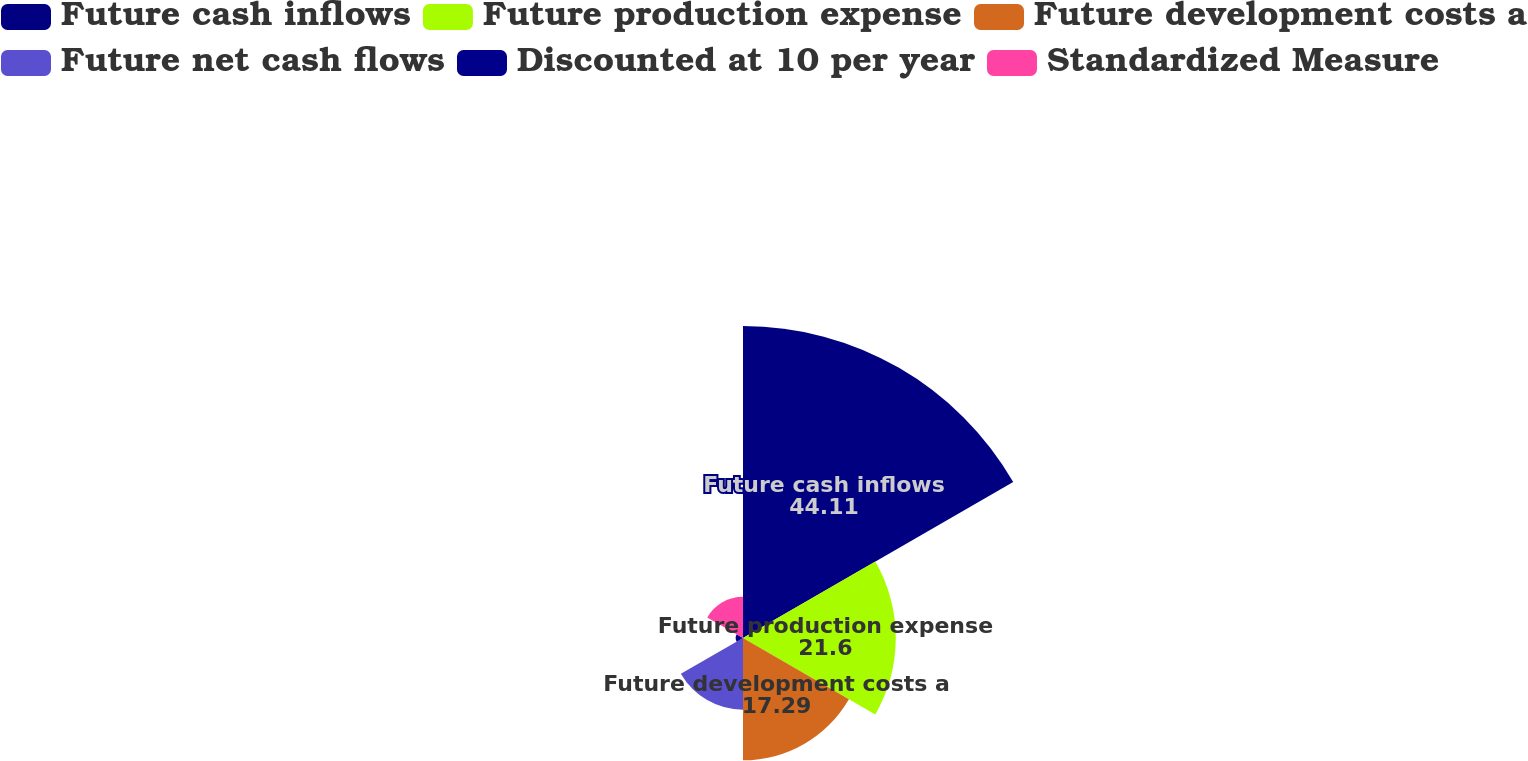<chart> <loc_0><loc_0><loc_500><loc_500><pie_chart><fcel>Future cash inflows<fcel>Future production expense<fcel>Future development costs a<fcel>Future net cash flows<fcel>Discounted at 10 per year<fcel>Standardized Measure<nl><fcel>44.11%<fcel>21.6%<fcel>17.29%<fcel>10.14%<fcel>1.03%<fcel>5.83%<nl></chart> 